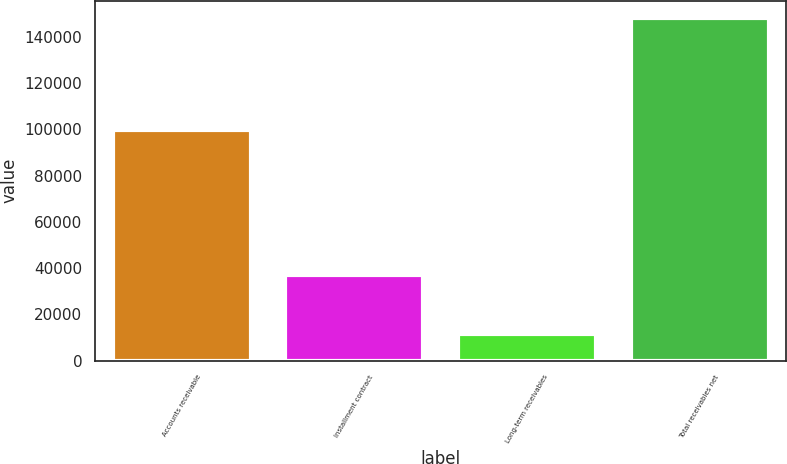Convert chart. <chart><loc_0><loc_0><loc_500><loc_500><bar_chart><fcel>Accounts receivable<fcel>Installment contract<fcel>Long-term receivables<fcel>Total receivables net<nl><fcel>99686<fcel>37086<fcel>11371<fcel>148143<nl></chart> 